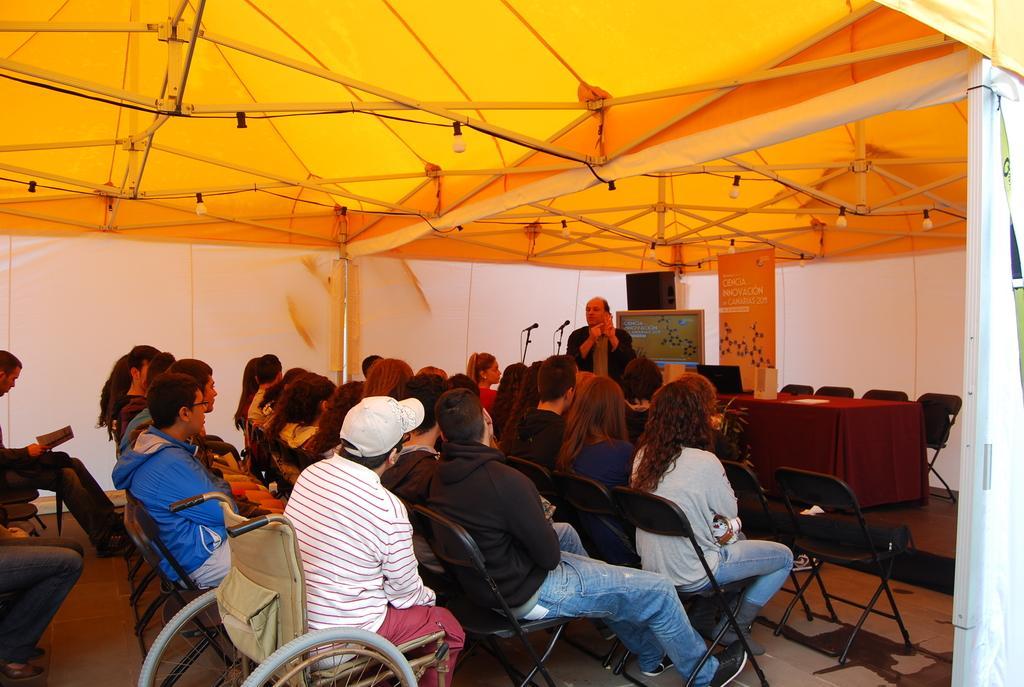Can you describe this image briefly? This picture describes about group of people, few are seated on the chairs, and a man is standing, in front of him we can find microphones, and we can see tent. 